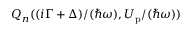<formula> <loc_0><loc_0><loc_500><loc_500>Q _ { n } ( { ( i \Gamma + \Delta ) } / { ( \hbar { \omega } ) } , { U _ { p } } / { ( \hbar { \omega } ) } )</formula> 